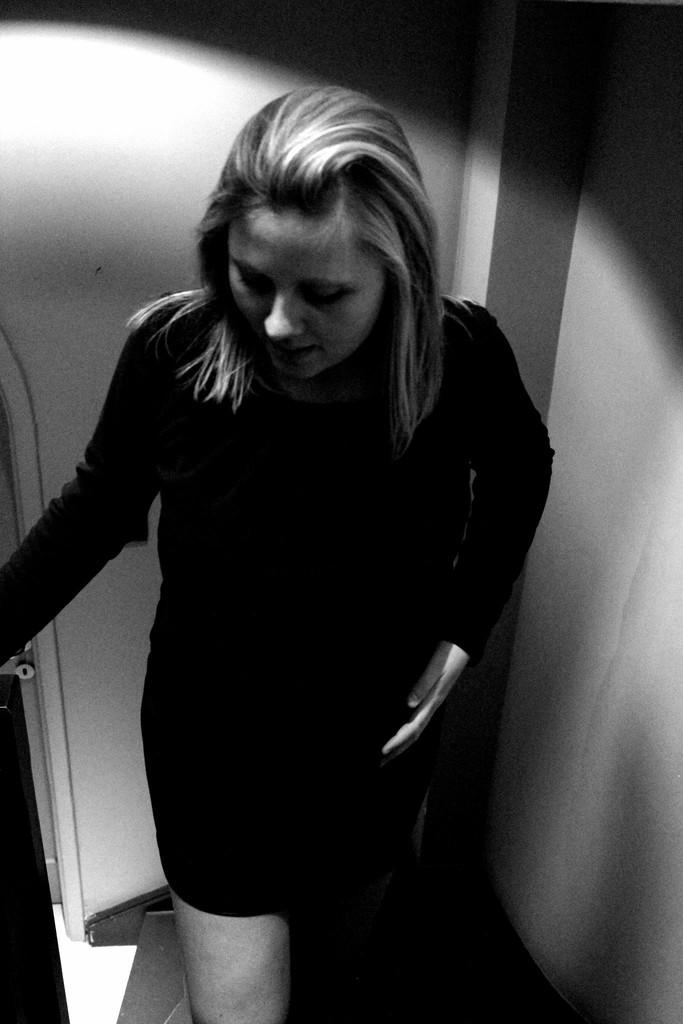What is the color scheme of the image? The image is in black and white. Who is present in the image? There is a woman in the image. What is the woman wearing? The woman is wearing a black dress. How is the woman described? The woman is described as stunning. What can be seen in the background of the image? There is a white wall in the background of the image. What type of base is supporting the clam in the image? There is no clam or base present in the image; it features a woman in a black dress with a white wall in the background. 